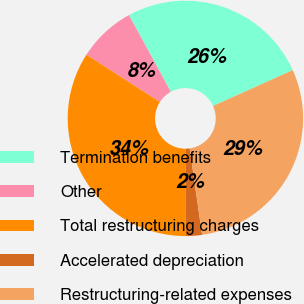Convert chart to OTSL. <chart><loc_0><loc_0><loc_500><loc_500><pie_chart><fcel>Termination benefits<fcel>Other<fcel>Total restructuring charges<fcel>Accelerated depreciation<fcel>Restructuring-related expenses<nl><fcel>26.25%<fcel>7.93%<fcel>34.18%<fcel>2.19%<fcel>29.45%<nl></chart> 